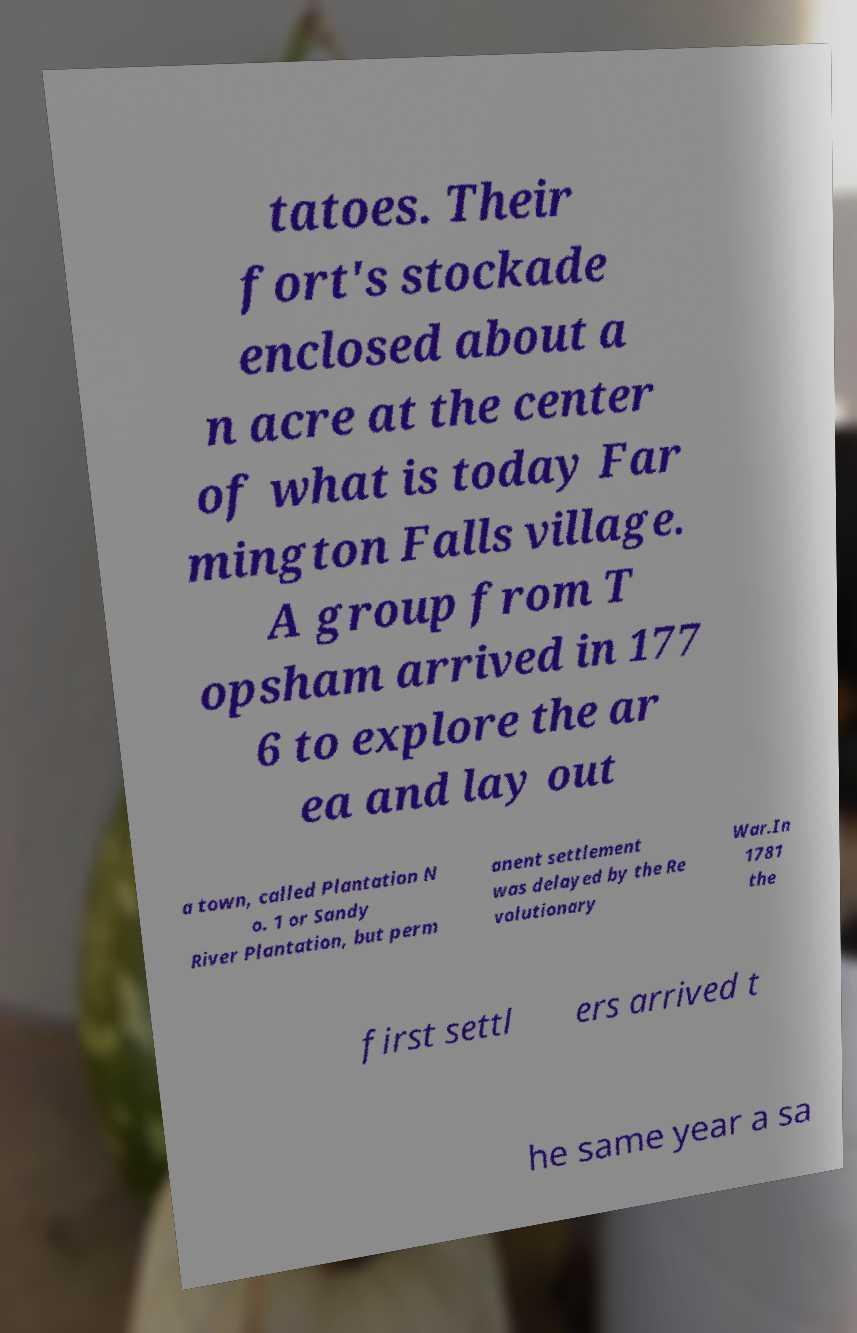Could you extract and type out the text from this image? tatoes. Their fort's stockade enclosed about a n acre at the center of what is today Far mington Falls village. A group from T opsham arrived in 177 6 to explore the ar ea and lay out a town, called Plantation N o. 1 or Sandy River Plantation, but perm anent settlement was delayed by the Re volutionary War.In 1781 the first settl ers arrived t he same year a sa 